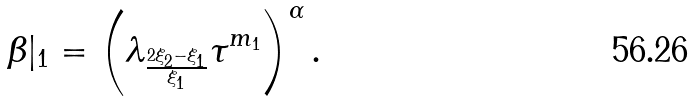Convert formula to latex. <formula><loc_0><loc_0><loc_500><loc_500>\beta | _ { 1 } = \left ( \lambda _ { \frac { 2 \xi _ { 2 } - \xi _ { 1 } } { \xi _ { 1 } } } \tau ^ { m _ { 1 } } \right ) ^ { \alpha } \text {.}</formula> 